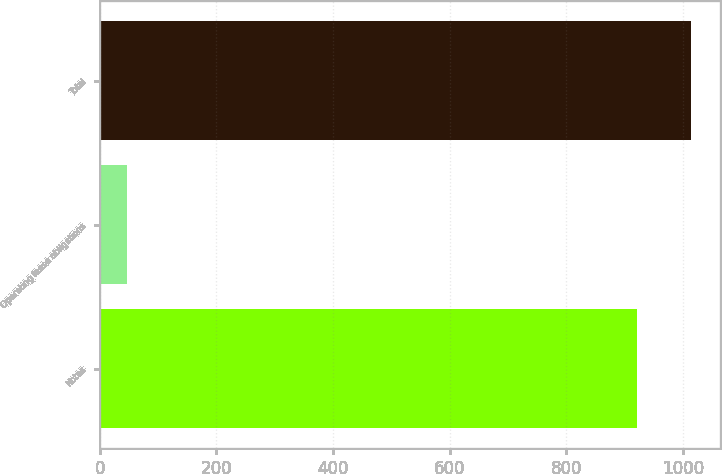Convert chart. <chart><loc_0><loc_0><loc_500><loc_500><bar_chart><fcel>Notes<fcel>Operating lease obligations<fcel>Total<nl><fcel>921.4<fcel>45.8<fcel>1013.54<nl></chart> 